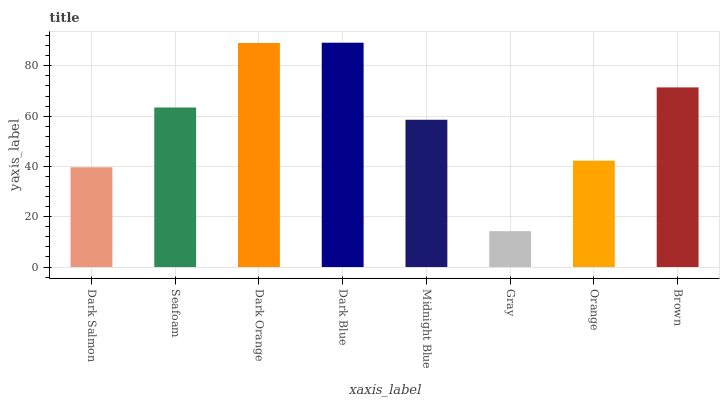Is Gray the minimum?
Answer yes or no. Yes. Is Dark Blue the maximum?
Answer yes or no. Yes. Is Seafoam the minimum?
Answer yes or no. No. Is Seafoam the maximum?
Answer yes or no. No. Is Seafoam greater than Dark Salmon?
Answer yes or no. Yes. Is Dark Salmon less than Seafoam?
Answer yes or no. Yes. Is Dark Salmon greater than Seafoam?
Answer yes or no. No. Is Seafoam less than Dark Salmon?
Answer yes or no. No. Is Seafoam the high median?
Answer yes or no. Yes. Is Midnight Blue the low median?
Answer yes or no. Yes. Is Brown the high median?
Answer yes or no. No. Is Brown the low median?
Answer yes or no. No. 